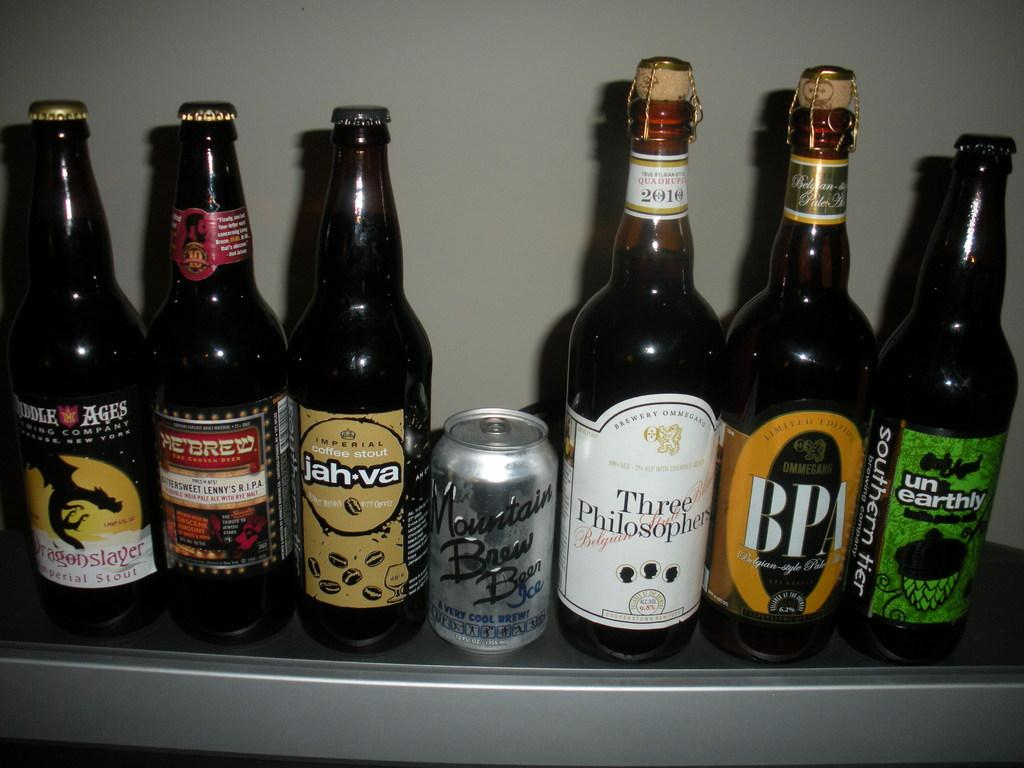Provide a one-sentence caption for the provided image. Bottles of booze lined up on a shelf with mountain brew being in the center. 